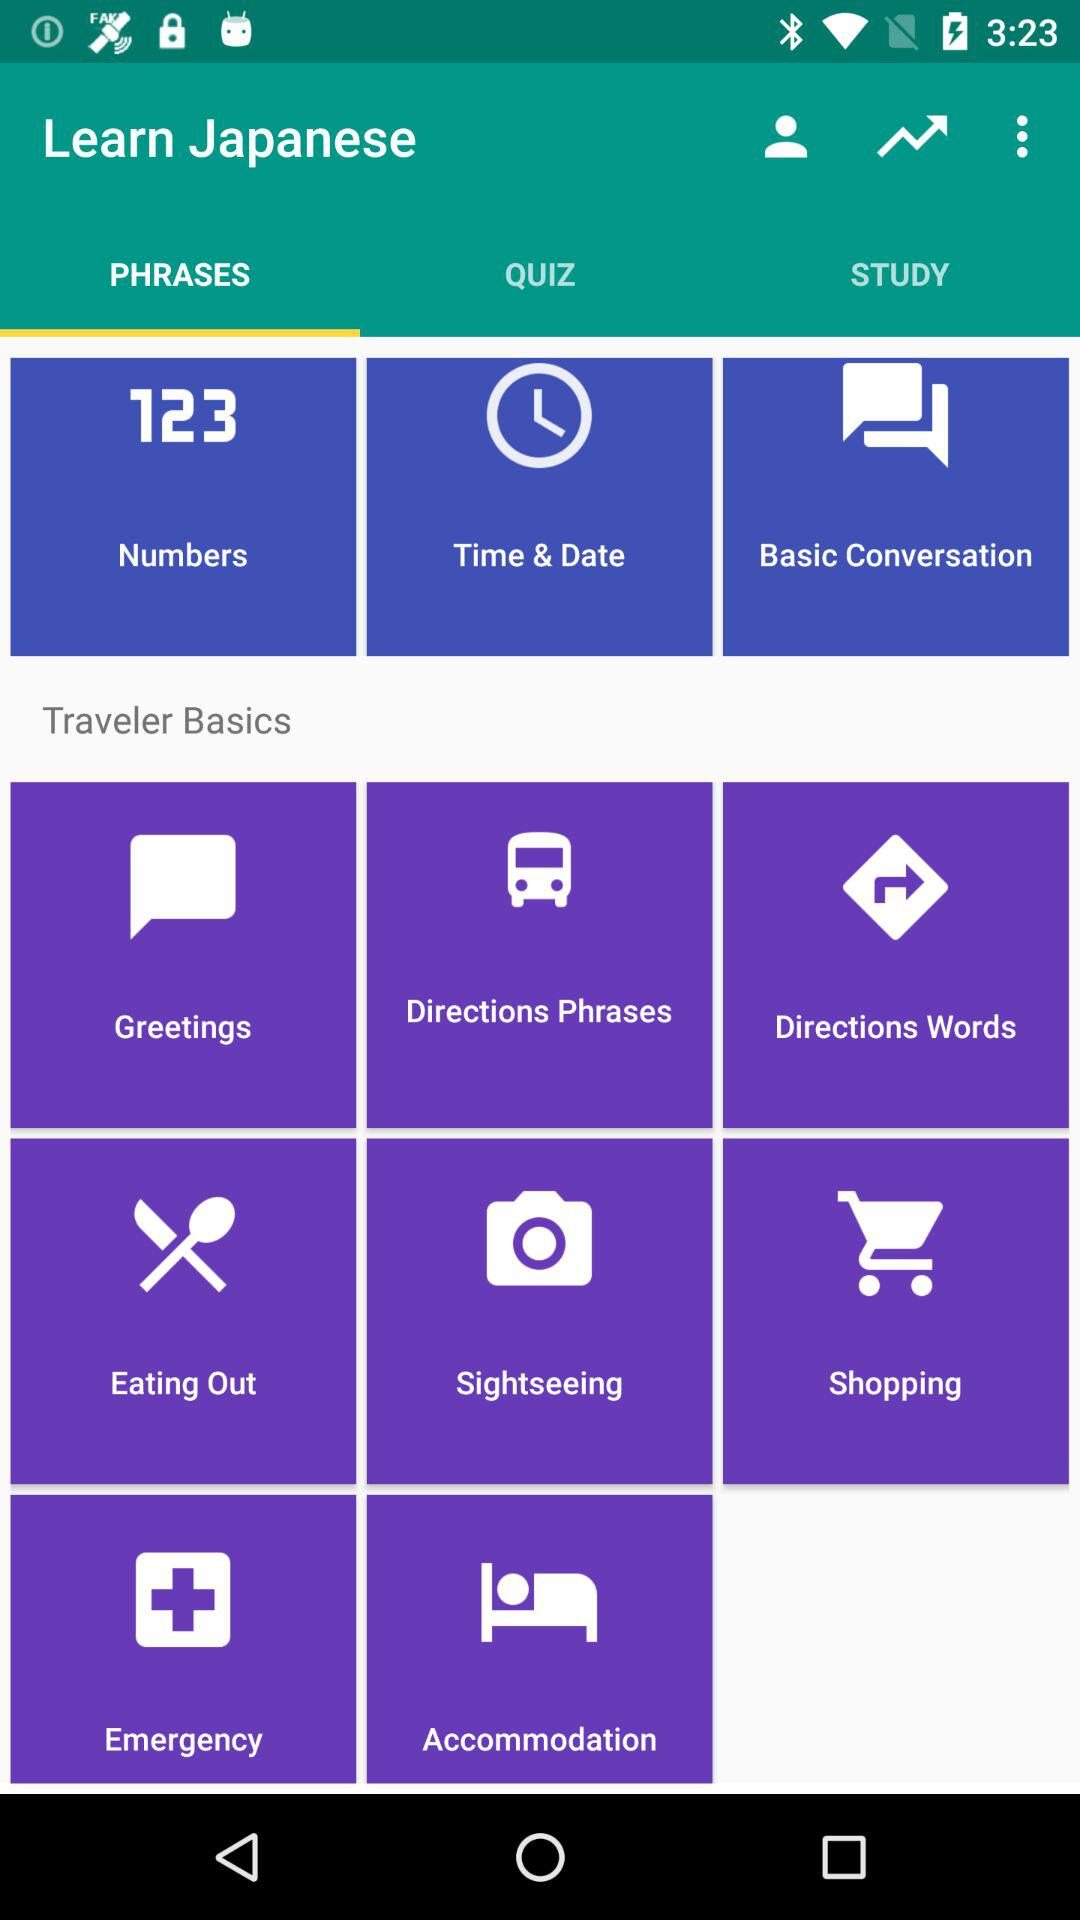What are the options available? The options available are "PHRASES", "QUIZ" and "STUDY". 